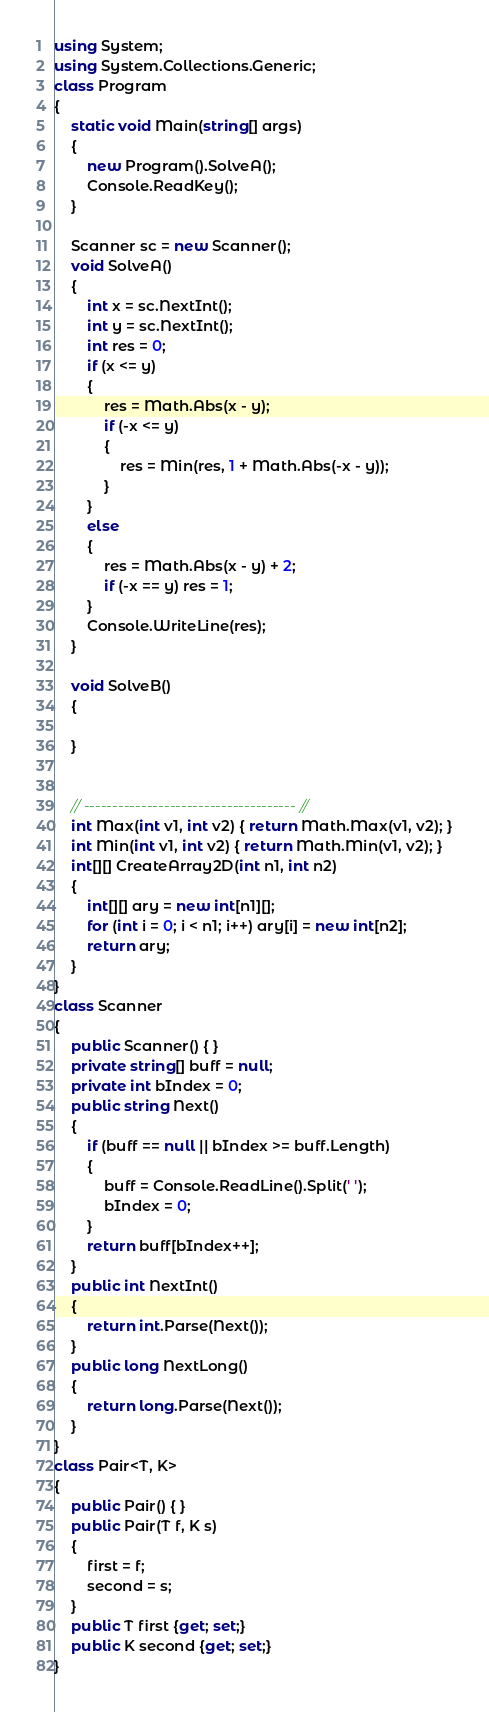<code> <loc_0><loc_0><loc_500><loc_500><_C#_>using System;
using System.Collections.Generic;
class Program
{
    static void Main(string[] args)
    {
        new Program().SolveA();
        Console.ReadKey();
    }

    Scanner sc = new Scanner();
    void SolveA()
    {
        int x = sc.NextInt();
        int y = sc.NextInt();
        int res = 0;
        if (x <= y)
        {
            res = Math.Abs(x - y);
            if (-x <= y)
            {
                res = Min(res, 1 + Math.Abs(-x - y));
            }
        }
        else
        {
            res = Math.Abs(x - y) + 2;
            if (-x == y) res = 1;
        }
        Console.WriteLine(res);
    }

    void SolveB()
    {

    }


    // ------------------------------------- //
    int Max(int v1, int v2) { return Math.Max(v1, v2); }
    int Min(int v1, int v2) { return Math.Min(v1, v2); }
    int[][] CreateArray2D(int n1, int n2)
    {
        int[][] ary = new int[n1][];
        for (int i = 0; i < n1; i++) ary[i] = new int[n2];
        return ary;
    }
}
class Scanner
{
    public Scanner() { }
    private string[] buff = null;
    private int bIndex = 0;
    public string Next()
    {
        if (buff == null || bIndex >= buff.Length)
        {
            buff = Console.ReadLine().Split(' ');
            bIndex = 0;
        }
        return buff[bIndex++];
    }
    public int NextInt()
    {
        return int.Parse(Next());
    }
    public long NextLong()
    {
        return long.Parse(Next());
    }
}
class Pair<T, K>
{
    public Pair() { }
    public Pair(T f, K s)
    {
        first = f;
        second = s;
    }
    public T first {get; set;}
    public K second {get; set;}
}</code> 